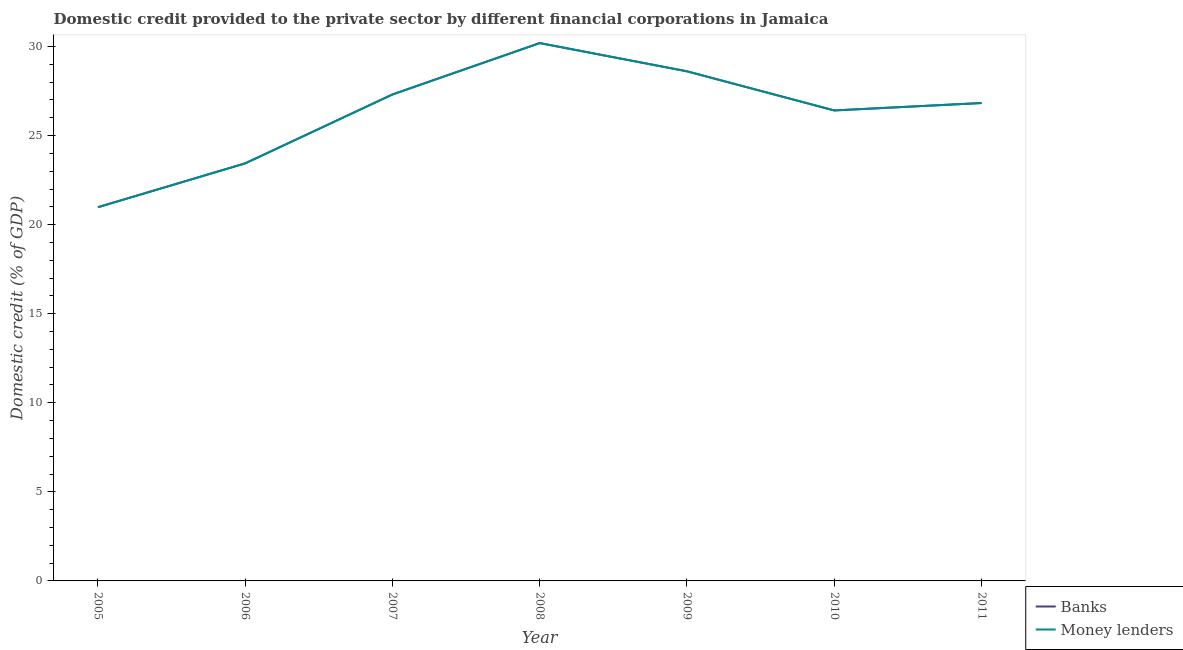How many different coloured lines are there?
Offer a terse response. 2. Does the line corresponding to domestic credit provided by banks intersect with the line corresponding to domestic credit provided by money lenders?
Ensure brevity in your answer.  Yes. Is the number of lines equal to the number of legend labels?
Provide a succinct answer. Yes. What is the domestic credit provided by banks in 2009?
Your answer should be very brief. 28.61. Across all years, what is the maximum domestic credit provided by money lenders?
Keep it short and to the point. 30.19. Across all years, what is the minimum domestic credit provided by money lenders?
Ensure brevity in your answer.  20.98. In which year was the domestic credit provided by money lenders maximum?
Provide a short and direct response. 2008. In which year was the domestic credit provided by money lenders minimum?
Keep it short and to the point. 2005. What is the total domestic credit provided by money lenders in the graph?
Provide a succinct answer. 183.76. What is the difference between the domestic credit provided by money lenders in 2005 and that in 2008?
Offer a terse response. -9.21. What is the difference between the domestic credit provided by money lenders in 2011 and the domestic credit provided by banks in 2005?
Provide a succinct answer. 5.85. What is the average domestic credit provided by banks per year?
Offer a very short reply. 26.25. What is the ratio of the domestic credit provided by banks in 2005 to that in 2008?
Your answer should be very brief. 0.69. Is the domestic credit provided by money lenders in 2006 less than that in 2010?
Give a very brief answer. Yes. What is the difference between the highest and the second highest domestic credit provided by banks?
Keep it short and to the point. 1.58. What is the difference between the highest and the lowest domestic credit provided by banks?
Keep it short and to the point. 9.21. Is the sum of the domestic credit provided by banks in 2006 and 2007 greater than the maximum domestic credit provided by money lenders across all years?
Your response must be concise. Yes. Does the domestic credit provided by money lenders monotonically increase over the years?
Give a very brief answer. No. How many lines are there?
Provide a short and direct response. 2. What is the difference between two consecutive major ticks on the Y-axis?
Provide a short and direct response. 5. Where does the legend appear in the graph?
Ensure brevity in your answer.  Bottom right. How are the legend labels stacked?
Make the answer very short. Vertical. What is the title of the graph?
Offer a very short reply. Domestic credit provided to the private sector by different financial corporations in Jamaica. Does "Short-term debt" appear as one of the legend labels in the graph?
Give a very brief answer. No. What is the label or title of the X-axis?
Offer a very short reply. Year. What is the label or title of the Y-axis?
Make the answer very short. Domestic credit (% of GDP). What is the Domestic credit (% of GDP) in Banks in 2005?
Your response must be concise. 20.98. What is the Domestic credit (% of GDP) of Money lenders in 2005?
Offer a terse response. 20.98. What is the Domestic credit (% of GDP) of Banks in 2006?
Ensure brevity in your answer.  23.44. What is the Domestic credit (% of GDP) of Money lenders in 2006?
Offer a very short reply. 23.44. What is the Domestic credit (% of GDP) of Banks in 2007?
Your answer should be compact. 27.31. What is the Domestic credit (% of GDP) in Money lenders in 2007?
Offer a terse response. 27.31. What is the Domestic credit (% of GDP) in Banks in 2008?
Your answer should be very brief. 30.19. What is the Domestic credit (% of GDP) of Money lenders in 2008?
Make the answer very short. 30.19. What is the Domestic credit (% of GDP) in Banks in 2009?
Your response must be concise. 28.61. What is the Domestic credit (% of GDP) in Money lenders in 2009?
Your answer should be compact. 28.61. What is the Domestic credit (% of GDP) of Banks in 2010?
Provide a succinct answer. 26.41. What is the Domestic credit (% of GDP) of Money lenders in 2010?
Provide a short and direct response. 26.41. What is the Domestic credit (% of GDP) in Banks in 2011?
Your answer should be very brief. 26.83. What is the Domestic credit (% of GDP) of Money lenders in 2011?
Keep it short and to the point. 26.83. Across all years, what is the maximum Domestic credit (% of GDP) of Banks?
Your answer should be very brief. 30.19. Across all years, what is the maximum Domestic credit (% of GDP) in Money lenders?
Offer a terse response. 30.19. Across all years, what is the minimum Domestic credit (% of GDP) of Banks?
Offer a very short reply. 20.98. Across all years, what is the minimum Domestic credit (% of GDP) of Money lenders?
Make the answer very short. 20.98. What is the total Domestic credit (% of GDP) in Banks in the graph?
Make the answer very short. 183.76. What is the total Domestic credit (% of GDP) of Money lenders in the graph?
Your answer should be compact. 183.76. What is the difference between the Domestic credit (% of GDP) in Banks in 2005 and that in 2006?
Your response must be concise. -2.46. What is the difference between the Domestic credit (% of GDP) in Money lenders in 2005 and that in 2006?
Keep it short and to the point. -2.46. What is the difference between the Domestic credit (% of GDP) in Banks in 2005 and that in 2007?
Your response must be concise. -6.33. What is the difference between the Domestic credit (% of GDP) of Money lenders in 2005 and that in 2007?
Provide a succinct answer. -6.33. What is the difference between the Domestic credit (% of GDP) in Banks in 2005 and that in 2008?
Keep it short and to the point. -9.21. What is the difference between the Domestic credit (% of GDP) in Money lenders in 2005 and that in 2008?
Make the answer very short. -9.21. What is the difference between the Domestic credit (% of GDP) in Banks in 2005 and that in 2009?
Provide a succinct answer. -7.63. What is the difference between the Domestic credit (% of GDP) in Money lenders in 2005 and that in 2009?
Your answer should be compact. -7.63. What is the difference between the Domestic credit (% of GDP) in Banks in 2005 and that in 2010?
Offer a very short reply. -5.43. What is the difference between the Domestic credit (% of GDP) in Money lenders in 2005 and that in 2010?
Offer a very short reply. -5.43. What is the difference between the Domestic credit (% of GDP) of Banks in 2005 and that in 2011?
Your answer should be compact. -5.85. What is the difference between the Domestic credit (% of GDP) in Money lenders in 2005 and that in 2011?
Make the answer very short. -5.85. What is the difference between the Domestic credit (% of GDP) in Banks in 2006 and that in 2007?
Provide a succinct answer. -3.87. What is the difference between the Domestic credit (% of GDP) of Money lenders in 2006 and that in 2007?
Offer a very short reply. -3.87. What is the difference between the Domestic credit (% of GDP) in Banks in 2006 and that in 2008?
Give a very brief answer. -6.75. What is the difference between the Domestic credit (% of GDP) in Money lenders in 2006 and that in 2008?
Keep it short and to the point. -6.75. What is the difference between the Domestic credit (% of GDP) in Banks in 2006 and that in 2009?
Keep it short and to the point. -5.17. What is the difference between the Domestic credit (% of GDP) of Money lenders in 2006 and that in 2009?
Make the answer very short. -5.17. What is the difference between the Domestic credit (% of GDP) in Banks in 2006 and that in 2010?
Make the answer very short. -2.97. What is the difference between the Domestic credit (% of GDP) in Money lenders in 2006 and that in 2010?
Your answer should be very brief. -2.97. What is the difference between the Domestic credit (% of GDP) in Banks in 2006 and that in 2011?
Keep it short and to the point. -3.39. What is the difference between the Domestic credit (% of GDP) of Money lenders in 2006 and that in 2011?
Make the answer very short. -3.39. What is the difference between the Domestic credit (% of GDP) of Banks in 2007 and that in 2008?
Provide a succinct answer. -2.88. What is the difference between the Domestic credit (% of GDP) of Money lenders in 2007 and that in 2008?
Your answer should be very brief. -2.88. What is the difference between the Domestic credit (% of GDP) of Banks in 2007 and that in 2009?
Your response must be concise. -1.3. What is the difference between the Domestic credit (% of GDP) in Banks in 2007 and that in 2010?
Your answer should be very brief. 0.9. What is the difference between the Domestic credit (% of GDP) in Money lenders in 2007 and that in 2010?
Your response must be concise. 0.9. What is the difference between the Domestic credit (% of GDP) in Banks in 2007 and that in 2011?
Offer a terse response. 0.48. What is the difference between the Domestic credit (% of GDP) in Money lenders in 2007 and that in 2011?
Provide a succinct answer. 0.48. What is the difference between the Domestic credit (% of GDP) of Banks in 2008 and that in 2009?
Your answer should be compact. 1.58. What is the difference between the Domestic credit (% of GDP) of Money lenders in 2008 and that in 2009?
Ensure brevity in your answer.  1.58. What is the difference between the Domestic credit (% of GDP) of Banks in 2008 and that in 2010?
Provide a succinct answer. 3.78. What is the difference between the Domestic credit (% of GDP) in Money lenders in 2008 and that in 2010?
Keep it short and to the point. 3.78. What is the difference between the Domestic credit (% of GDP) in Banks in 2008 and that in 2011?
Provide a succinct answer. 3.36. What is the difference between the Domestic credit (% of GDP) of Money lenders in 2008 and that in 2011?
Your answer should be compact. 3.36. What is the difference between the Domestic credit (% of GDP) in Banks in 2009 and that in 2010?
Your answer should be very brief. 2.2. What is the difference between the Domestic credit (% of GDP) in Money lenders in 2009 and that in 2010?
Your answer should be compact. 2.2. What is the difference between the Domestic credit (% of GDP) of Banks in 2009 and that in 2011?
Your answer should be compact. 1.78. What is the difference between the Domestic credit (% of GDP) of Money lenders in 2009 and that in 2011?
Your response must be concise. 1.78. What is the difference between the Domestic credit (% of GDP) in Banks in 2010 and that in 2011?
Give a very brief answer. -0.42. What is the difference between the Domestic credit (% of GDP) of Money lenders in 2010 and that in 2011?
Your response must be concise. -0.42. What is the difference between the Domestic credit (% of GDP) in Banks in 2005 and the Domestic credit (% of GDP) in Money lenders in 2006?
Your response must be concise. -2.46. What is the difference between the Domestic credit (% of GDP) in Banks in 2005 and the Domestic credit (% of GDP) in Money lenders in 2007?
Offer a very short reply. -6.33. What is the difference between the Domestic credit (% of GDP) in Banks in 2005 and the Domestic credit (% of GDP) in Money lenders in 2008?
Provide a short and direct response. -9.21. What is the difference between the Domestic credit (% of GDP) of Banks in 2005 and the Domestic credit (% of GDP) of Money lenders in 2009?
Your answer should be very brief. -7.63. What is the difference between the Domestic credit (% of GDP) of Banks in 2005 and the Domestic credit (% of GDP) of Money lenders in 2010?
Offer a terse response. -5.43. What is the difference between the Domestic credit (% of GDP) of Banks in 2005 and the Domestic credit (% of GDP) of Money lenders in 2011?
Provide a short and direct response. -5.85. What is the difference between the Domestic credit (% of GDP) in Banks in 2006 and the Domestic credit (% of GDP) in Money lenders in 2007?
Give a very brief answer. -3.87. What is the difference between the Domestic credit (% of GDP) of Banks in 2006 and the Domestic credit (% of GDP) of Money lenders in 2008?
Your answer should be compact. -6.75. What is the difference between the Domestic credit (% of GDP) in Banks in 2006 and the Domestic credit (% of GDP) in Money lenders in 2009?
Provide a succinct answer. -5.17. What is the difference between the Domestic credit (% of GDP) of Banks in 2006 and the Domestic credit (% of GDP) of Money lenders in 2010?
Provide a succinct answer. -2.97. What is the difference between the Domestic credit (% of GDP) in Banks in 2006 and the Domestic credit (% of GDP) in Money lenders in 2011?
Your answer should be compact. -3.39. What is the difference between the Domestic credit (% of GDP) of Banks in 2007 and the Domestic credit (% of GDP) of Money lenders in 2008?
Your response must be concise. -2.88. What is the difference between the Domestic credit (% of GDP) of Banks in 2007 and the Domestic credit (% of GDP) of Money lenders in 2009?
Keep it short and to the point. -1.3. What is the difference between the Domestic credit (% of GDP) of Banks in 2007 and the Domestic credit (% of GDP) of Money lenders in 2010?
Offer a very short reply. 0.9. What is the difference between the Domestic credit (% of GDP) in Banks in 2007 and the Domestic credit (% of GDP) in Money lenders in 2011?
Offer a very short reply. 0.48. What is the difference between the Domestic credit (% of GDP) in Banks in 2008 and the Domestic credit (% of GDP) in Money lenders in 2009?
Your answer should be compact. 1.58. What is the difference between the Domestic credit (% of GDP) in Banks in 2008 and the Domestic credit (% of GDP) in Money lenders in 2010?
Give a very brief answer. 3.78. What is the difference between the Domestic credit (% of GDP) of Banks in 2008 and the Domestic credit (% of GDP) of Money lenders in 2011?
Offer a terse response. 3.36. What is the difference between the Domestic credit (% of GDP) of Banks in 2009 and the Domestic credit (% of GDP) of Money lenders in 2010?
Provide a succinct answer. 2.2. What is the difference between the Domestic credit (% of GDP) of Banks in 2009 and the Domestic credit (% of GDP) of Money lenders in 2011?
Offer a very short reply. 1.78. What is the difference between the Domestic credit (% of GDP) in Banks in 2010 and the Domestic credit (% of GDP) in Money lenders in 2011?
Provide a short and direct response. -0.42. What is the average Domestic credit (% of GDP) in Banks per year?
Your answer should be very brief. 26.25. What is the average Domestic credit (% of GDP) in Money lenders per year?
Offer a terse response. 26.25. In the year 2005, what is the difference between the Domestic credit (% of GDP) of Banks and Domestic credit (% of GDP) of Money lenders?
Keep it short and to the point. 0. In the year 2007, what is the difference between the Domestic credit (% of GDP) in Banks and Domestic credit (% of GDP) in Money lenders?
Give a very brief answer. 0. In the year 2008, what is the difference between the Domestic credit (% of GDP) in Banks and Domestic credit (% of GDP) in Money lenders?
Your response must be concise. 0. In the year 2010, what is the difference between the Domestic credit (% of GDP) in Banks and Domestic credit (% of GDP) in Money lenders?
Your response must be concise. 0. What is the ratio of the Domestic credit (% of GDP) of Banks in 2005 to that in 2006?
Give a very brief answer. 0.9. What is the ratio of the Domestic credit (% of GDP) in Money lenders in 2005 to that in 2006?
Your answer should be very brief. 0.9. What is the ratio of the Domestic credit (% of GDP) of Banks in 2005 to that in 2007?
Ensure brevity in your answer.  0.77. What is the ratio of the Domestic credit (% of GDP) of Money lenders in 2005 to that in 2007?
Offer a very short reply. 0.77. What is the ratio of the Domestic credit (% of GDP) in Banks in 2005 to that in 2008?
Provide a short and direct response. 0.69. What is the ratio of the Domestic credit (% of GDP) in Money lenders in 2005 to that in 2008?
Keep it short and to the point. 0.69. What is the ratio of the Domestic credit (% of GDP) in Banks in 2005 to that in 2009?
Your answer should be compact. 0.73. What is the ratio of the Domestic credit (% of GDP) in Money lenders in 2005 to that in 2009?
Your answer should be compact. 0.73. What is the ratio of the Domestic credit (% of GDP) in Banks in 2005 to that in 2010?
Your answer should be compact. 0.79. What is the ratio of the Domestic credit (% of GDP) of Money lenders in 2005 to that in 2010?
Offer a terse response. 0.79. What is the ratio of the Domestic credit (% of GDP) of Banks in 2005 to that in 2011?
Offer a very short reply. 0.78. What is the ratio of the Domestic credit (% of GDP) in Money lenders in 2005 to that in 2011?
Make the answer very short. 0.78. What is the ratio of the Domestic credit (% of GDP) of Banks in 2006 to that in 2007?
Offer a terse response. 0.86. What is the ratio of the Domestic credit (% of GDP) in Money lenders in 2006 to that in 2007?
Offer a terse response. 0.86. What is the ratio of the Domestic credit (% of GDP) in Banks in 2006 to that in 2008?
Offer a terse response. 0.78. What is the ratio of the Domestic credit (% of GDP) in Money lenders in 2006 to that in 2008?
Ensure brevity in your answer.  0.78. What is the ratio of the Domestic credit (% of GDP) in Banks in 2006 to that in 2009?
Keep it short and to the point. 0.82. What is the ratio of the Domestic credit (% of GDP) in Money lenders in 2006 to that in 2009?
Keep it short and to the point. 0.82. What is the ratio of the Domestic credit (% of GDP) of Banks in 2006 to that in 2010?
Your answer should be very brief. 0.89. What is the ratio of the Domestic credit (% of GDP) in Money lenders in 2006 to that in 2010?
Make the answer very short. 0.89. What is the ratio of the Domestic credit (% of GDP) in Banks in 2006 to that in 2011?
Keep it short and to the point. 0.87. What is the ratio of the Domestic credit (% of GDP) of Money lenders in 2006 to that in 2011?
Provide a succinct answer. 0.87. What is the ratio of the Domestic credit (% of GDP) in Banks in 2007 to that in 2008?
Your answer should be compact. 0.9. What is the ratio of the Domestic credit (% of GDP) in Money lenders in 2007 to that in 2008?
Offer a terse response. 0.9. What is the ratio of the Domestic credit (% of GDP) of Banks in 2007 to that in 2009?
Provide a short and direct response. 0.95. What is the ratio of the Domestic credit (% of GDP) of Money lenders in 2007 to that in 2009?
Provide a succinct answer. 0.95. What is the ratio of the Domestic credit (% of GDP) in Banks in 2007 to that in 2010?
Your response must be concise. 1.03. What is the ratio of the Domestic credit (% of GDP) of Money lenders in 2007 to that in 2010?
Ensure brevity in your answer.  1.03. What is the ratio of the Domestic credit (% of GDP) of Banks in 2007 to that in 2011?
Offer a very short reply. 1.02. What is the ratio of the Domestic credit (% of GDP) of Money lenders in 2007 to that in 2011?
Your answer should be very brief. 1.02. What is the ratio of the Domestic credit (% of GDP) of Banks in 2008 to that in 2009?
Ensure brevity in your answer.  1.06. What is the ratio of the Domestic credit (% of GDP) of Money lenders in 2008 to that in 2009?
Give a very brief answer. 1.06. What is the ratio of the Domestic credit (% of GDP) of Banks in 2008 to that in 2010?
Provide a succinct answer. 1.14. What is the ratio of the Domestic credit (% of GDP) in Money lenders in 2008 to that in 2010?
Provide a succinct answer. 1.14. What is the ratio of the Domestic credit (% of GDP) of Banks in 2008 to that in 2011?
Provide a succinct answer. 1.13. What is the ratio of the Domestic credit (% of GDP) in Money lenders in 2008 to that in 2011?
Make the answer very short. 1.13. What is the ratio of the Domestic credit (% of GDP) of Banks in 2009 to that in 2010?
Your answer should be compact. 1.08. What is the ratio of the Domestic credit (% of GDP) of Money lenders in 2009 to that in 2010?
Provide a short and direct response. 1.08. What is the ratio of the Domestic credit (% of GDP) in Banks in 2009 to that in 2011?
Your response must be concise. 1.07. What is the ratio of the Domestic credit (% of GDP) in Money lenders in 2009 to that in 2011?
Give a very brief answer. 1.07. What is the ratio of the Domestic credit (% of GDP) in Banks in 2010 to that in 2011?
Provide a succinct answer. 0.98. What is the ratio of the Domestic credit (% of GDP) of Money lenders in 2010 to that in 2011?
Provide a succinct answer. 0.98. What is the difference between the highest and the second highest Domestic credit (% of GDP) of Banks?
Offer a very short reply. 1.58. What is the difference between the highest and the second highest Domestic credit (% of GDP) of Money lenders?
Ensure brevity in your answer.  1.58. What is the difference between the highest and the lowest Domestic credit (% of GDP) of Banks?
Your answer should be very brief. 9.21. What is the difference between the highest and the lowest Domestic credit (% of GDP) of Money lenders?
Keep it short and to the point. 9.21. 